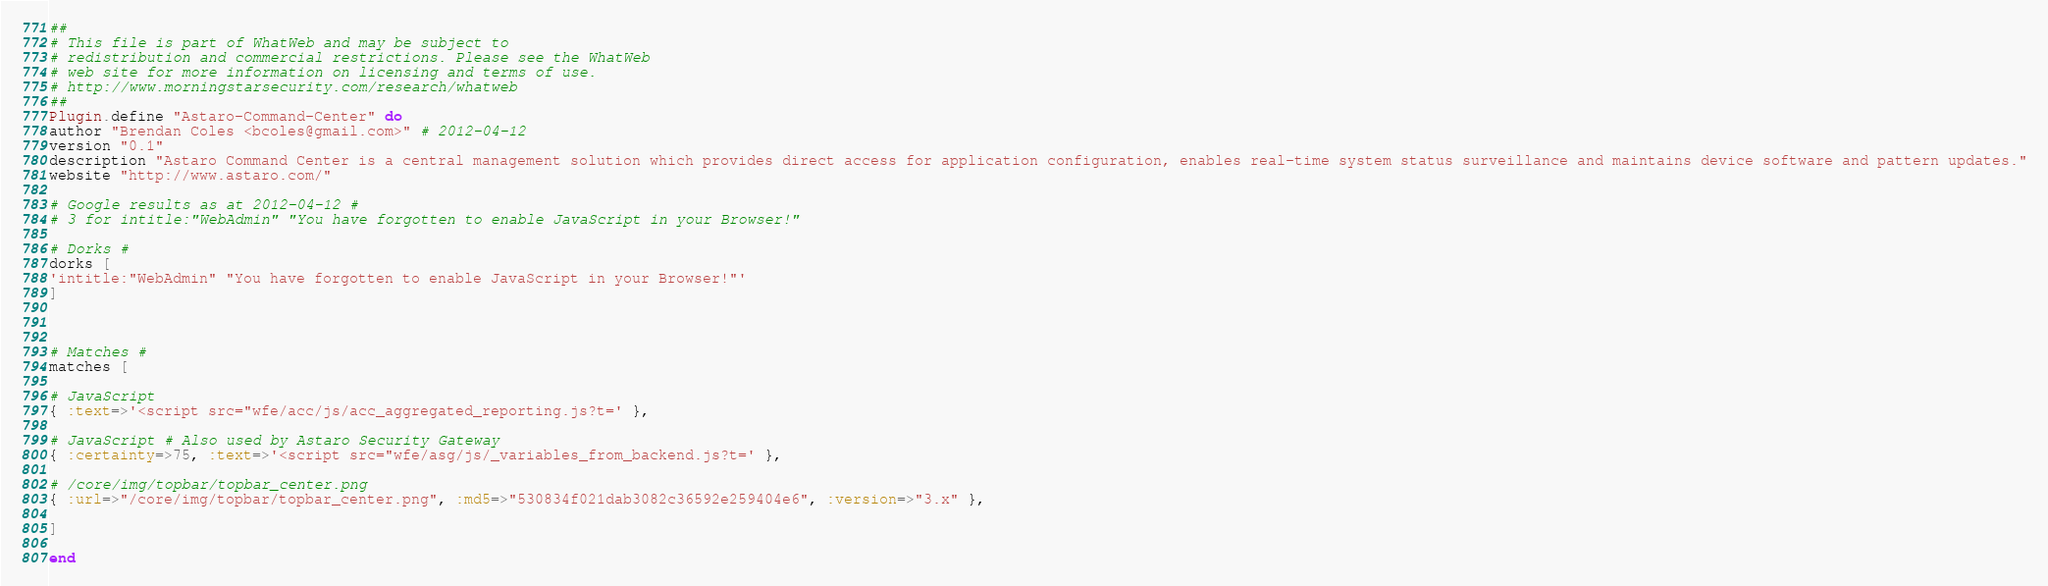Convert code to text. <code><loc_0><loc_0><loc_500><loc_500><_Ruby_>##
# This file is part of WhatWeb and may be subject to
# redistribution and commercial restrictions. Please see the WhatWeb
# web site for more information on licensing and terms of use.
# http://www.morningstarsecurity.com/research/whatweb
##
Plugin.define "Astaro-Command-Center" do
author "Brendan Coles <bcoles@gmail.com>" # 2012-04-12
version "0.1"
description "Astaro Command Center is a central management solution which provides direct access for application configuration, enables real-time system status surveillance and maintains device software and pattern updates."
website "http://www.astaro.com/"

# Google results as at 2012-04-12 #
# 3 for intitle:"WebAdmin" "You have forgotten to enable JavaScript in your Browser!"

# Dorks #
dorks [
'intitle:"WebAdmin" "You have forgotten to enable JavaScript in your Browser!"'
]



# Matches #
matches [

# JavaScript
{ :text=>'<script src="wfe/acc/js/acc_aggregated_reporting.js?t=' },

# JavaScript # Also used by Astaro Security Gateway
{ :certainty=>75, :text=>'<script src="wfe/asg/js/_variables_from_backend.js?t=' },

# /core/img/topbar/topbar_center.png
{ :url=>"/core/img/topbar/topbar_center.png", :md5=>"530834f021dab3082c36592e259404e6", :version=>"3.x" },

]

end

</code> 